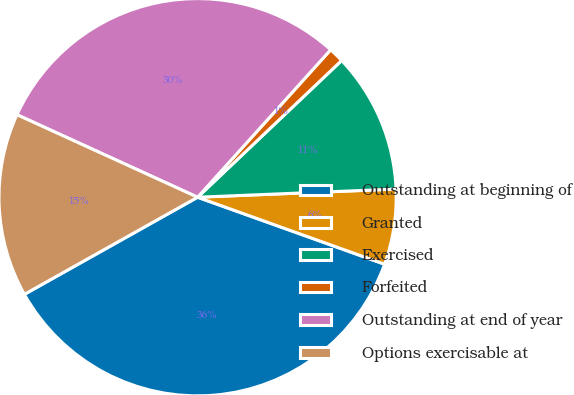<chart> <loc_0><loc_0><loc_500><loc_500><pie_chart><fcel>Outstanding at beginning of<fcel>Granted<fcel>Exercised<fcel>Forfeited<fcel>Outstanding at end of year<fcel>Options exercisable at<nl><fcel>36.39%<fcel>6.13%<fcel>11.43%<fcel>1.23%<fcel>29.86%<fcel>14.95%<nl></chart> 